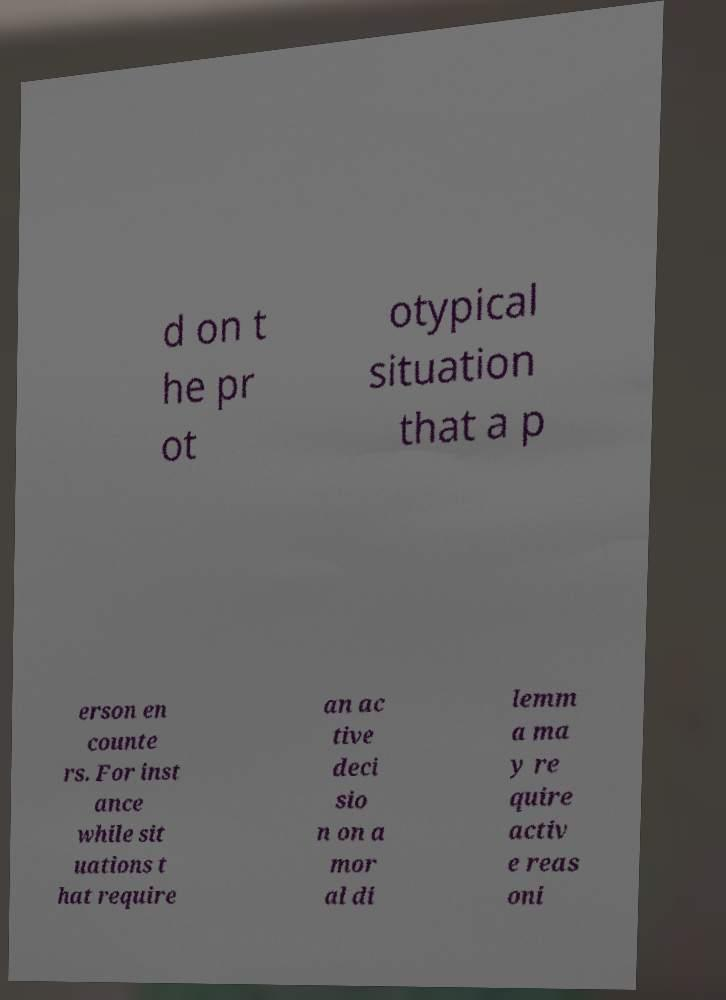Could you assist in decoding the text presented in this image and type it out clearly? d on t he pr ot otypical situation that a p erson en counte rs. For inst ance while sit uations t hat require an ac tive deci sio n on a mor al di lemm a ma y re quire activ e reas oni 